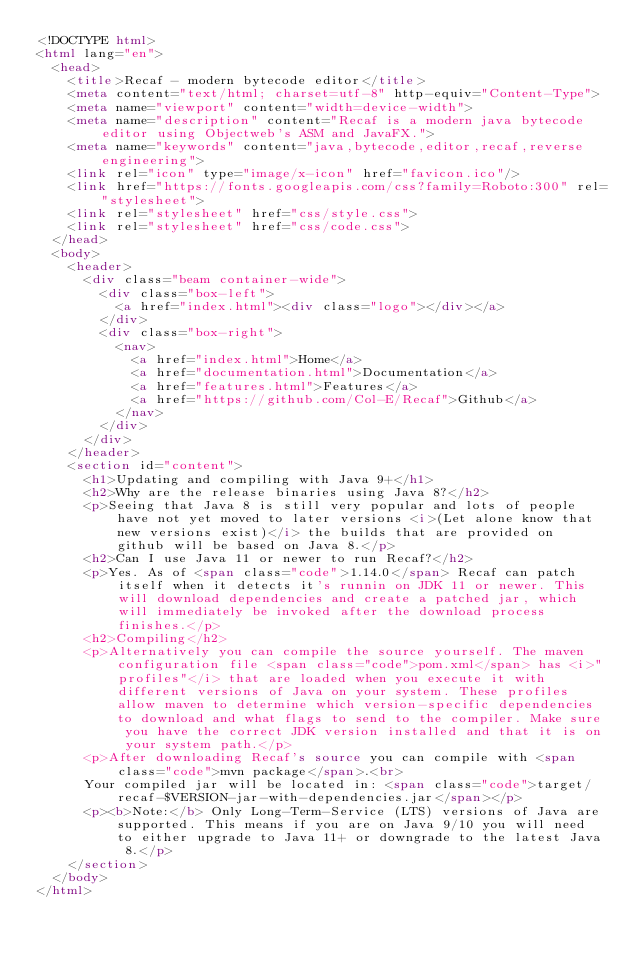<code> <loc_0><loc_0><loc_500><loc_500><_HTML_><!DOCTYPE html>
<html lang="en">
	<head>
		<title>Recaf - modern bytecode editor</title>
		<meta content="text/html; charset=utf-8" http-equiv="Content-Type">
		<meta name="viewport" content="width=device-width">
		<meta name="description" content="Recaf is a modern java bytecode editor using Objectweb's ASM and JavaFX.">
		<meta name="keywords" content="java,bytecode,editor,recaf,reverse engineering">
		<link rel="icon" type="image/x-icon" href="favicon.ico"/>
		<link href="https://fonts.googleapis.com/css?family=Roboto:300" rel="stylesheet">
		<link rel="stylesheet" href="css/style.css">
		<link rel="stylesheet" href="css/code.css">
	</head>
	<body>
		<header>
			<div class="beam container-wide">
				<div class="box-left">
					<a href="index.html"><div class="logo"></div></a>
				</div>
				<div class="box-right">
					<nav>
						<a href="index.html">Home</a>
						<a href="documentation.html">Documentation</a>
						<a href="features.html">Features</a>
						<a href="https://github.com/Col-E/Recaf">Github</a>
					</nav>
				</div>
			</div>
		</header>
		<section id="content">
			<h1>Updating and compiling with Java 9+</h1>
			<h2>Why are the release binaries using Java 8?</h2>
			<p>Seeing that Java 8 is still very popular and lots of people have not yet moved to later versions <i>(Let alone know that new versions exist)</i> the builds that are provided on github will be based on Java 8.</p>
			<h2>Can I use Java 11 or newer to run Recaf?</h2>
			<p>Yes. As of <span class="code">1.14.0</span> Recaf can patch itself when it detects it's runnin on JDK 11 or newer. This will download dependencies and create a patched jar, which will immediately be invoked after the download process finishes.</p>
			<h2>Compiling</h2>
			<p>Alternatively you can compile the source yourself. The maven configuration file <span class="code">pom.xml</span> has <i>"profiles"</i> that are loaded when you execute it with different versions of Java on your system. These profiles allow maven to determine which version-specific dependencies to download and what flags to send to the compiler. Make sure you have the correct JDK version installed and that it is on your system path.</p>
			<p>After downloading Recaf's source you can compile with <span class="code">mvn package</span>.<br>
			Your compiled jar will be located in: <span class="code">target/recaf-$VERSION-jar-with-dependencies.jar</span></p>
			<p><b>Note:</b> Only Long-Term-Service (LTS) versions of Java are supported. This means if you are on Java 9/10 you will need to either upgrade to Java 11+ or downgrade to the latest Java 8.</p>
		</section>
	</body>
</html></code> 